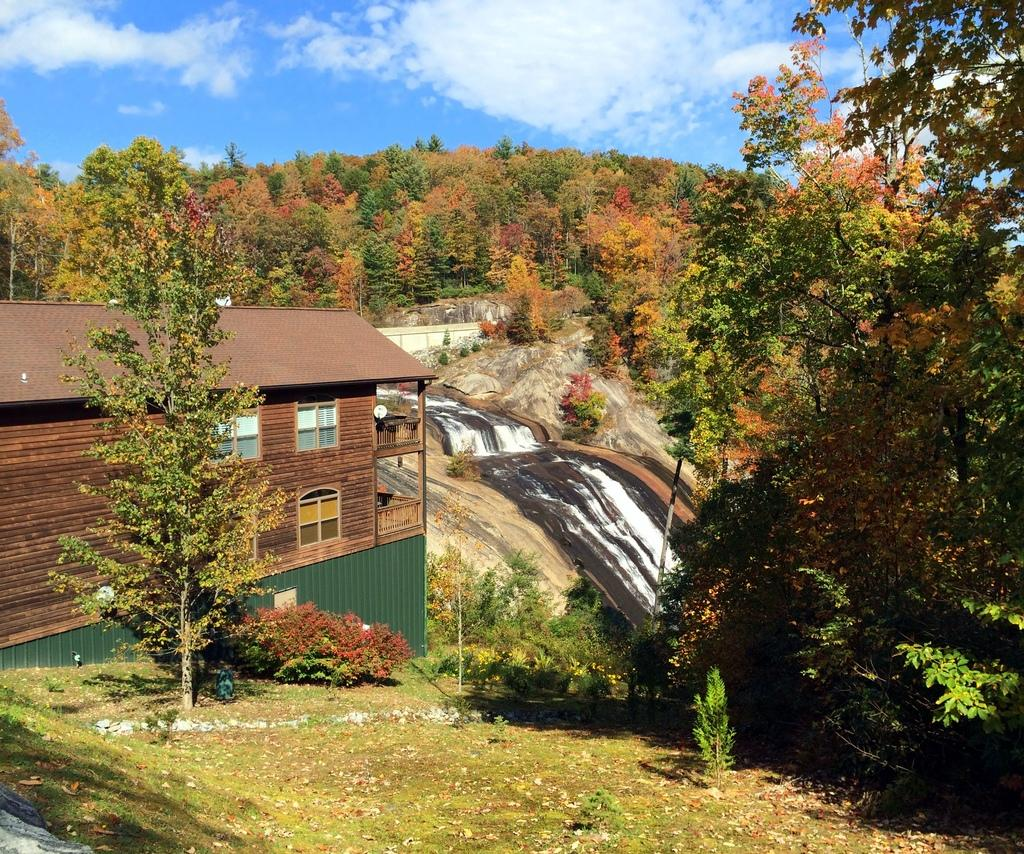What type of structure is present in the image? There is a building in the image. What feature of the building is mentioned in the facts? The building has windows. What natural elements can be seen in the image? There are trees, a water flow, grass, and rocks visible in the image. What part of the natural environment is visible in the image? The sky is visible in the image. What type of line is being used by the company in the image? There is no mention of a line or a company in the image. Is there a kite visible in the image? No, there is no kite present in the image. 